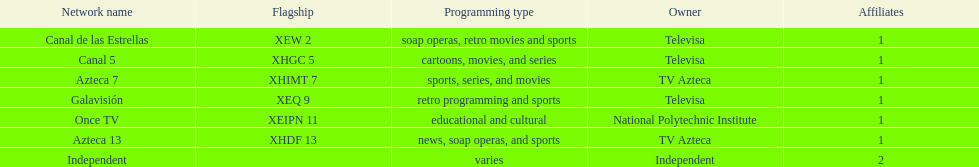Would you mind parsing the complete table? {'header': ['Network name', 'Flagship', 'Programming type', 'Owner', 'Affiliates'], 'rows': [['Canal de las Estrellas', 'XEW 2', 'soap operas, retro movies and sports', 'Televisa', '1'], ['Canal 5', 'XHGC 5', 'cartoons, movies, and series', 'Televisa', '1'], ['Azteca 7', 'XHIMT 7', 'sports, series, and movies', 'TV Azteca', '1'], ['Galavisión', 'XEQ 9', 'retro programming and sports', 'Televisa', '1'], ['Once TV', 'XEIPN 11', 'educational and cultural', 'National Polytechnic Institute', '1'], ['Azteca 13', 'XHDF 13', 'news, soap operas, and sports', 'TV Azteca', '1'], ['Independent', '', 'varies', 'Independent', '2']]} How many networks does televisa possess? 3. 